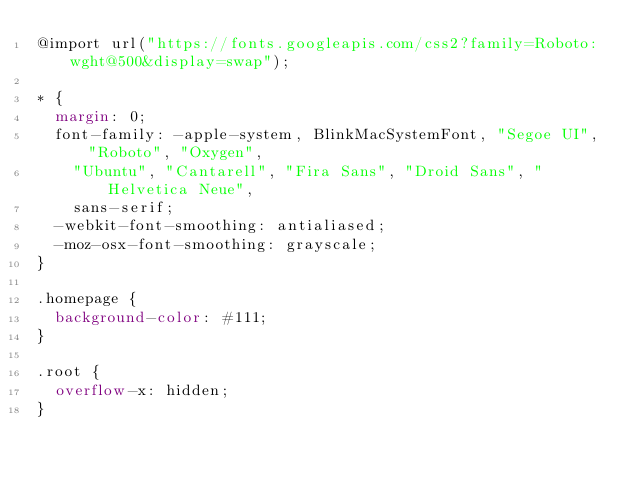<code> <loc_0><loc_0><loc_500><loc_500><_CSS_>@import url("https://fonts.googleapis.com/css2?family=Roboto:wght@500&display=swap");

* {
  margin: 0;
  font-family: -apple-system, BlinkMacSystemFont, "Segoe UI", "Roboto", "Oxygen",
    "Ubuntu", "Cantarell", "Fira Sans", "Droid Sans", "Helvetica Neue",
    sans-serif;
  -webkit-font-smoothing: antialiased;
  -moz-osx-font-smoothing: grayscale;
}

.homepage {
  background-color: #111;
}

.root {
  overflow-x: hidden;
}
</code> 